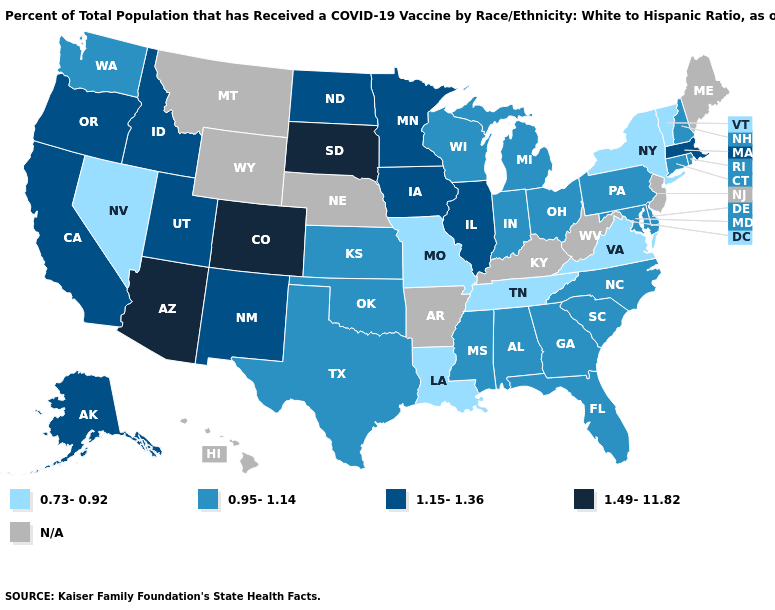Name the states that have a value in the range 1.15-1.36?
Quick response, please. Alaska, California, Idaho, Illinois, Iowa, Massachusetts, Minnesota, New Mexico, North Dakota, Oregon, Utah. Among the states that border Tennessee , which have the highest value?
Answer briefly. Alabama, Georgia, Mississippi, North Carolina. Does North Carolina have the highest value in the South?
Quick response, please. Yes. Name the states that have a value in the range 1.49-11.82?
Write a very short answer. Arizona, Colorado, South Dakota. Does New Mexico have the lowest value in the West?
Give a very brief answer. No. Name the states that have a value in the range 0.73-0.92?
Be succinct. Louisiana, Missouri, Nevada, New York, Tennessee, Vermont, Virginia. Name the states that have a value in the range 0.73-0.92?
Quick response, please. Louisiana, Missouri, Nevada, New York, Tennessee, Vermont, Virginia. What is the lowest value in the USA?
Short answer required. 0.73-0.92. What is the lowest value in the MidWest?
Short answer required. 0.73-0.92. Name the states that have a value in the range 0.73-0.92?
Quick response, please. Louisiana, Missouri, Nevada, New York, Tennessee, Vermont, Virginia. Name the states that have a value in the range 1.15-1.36?
Be succinct. Alaska, California, Idaho, Illinois, Iowa, Massachusetts, Minnesota, New Mexico, North Dakota, Oregon, Utah. Which states have the lowest value in the USA?
Quick response, please. Louisiana, Missouri, Nevada, New York, Tennessee, Vermont, Virginia. Which states have the lowest value in the USA?
Be succinct. Louisiana, Missouri, Nevada, New York, Tennessee, Vermont, Virginia. How many symbols are there in the legend?
Be succinct. 5. Name the states that have a value in the range 0.73-0.92?
Short answer required. Louisiana, Missouri, Nevada, New York, Tennessee, Vermont, Virginia. 